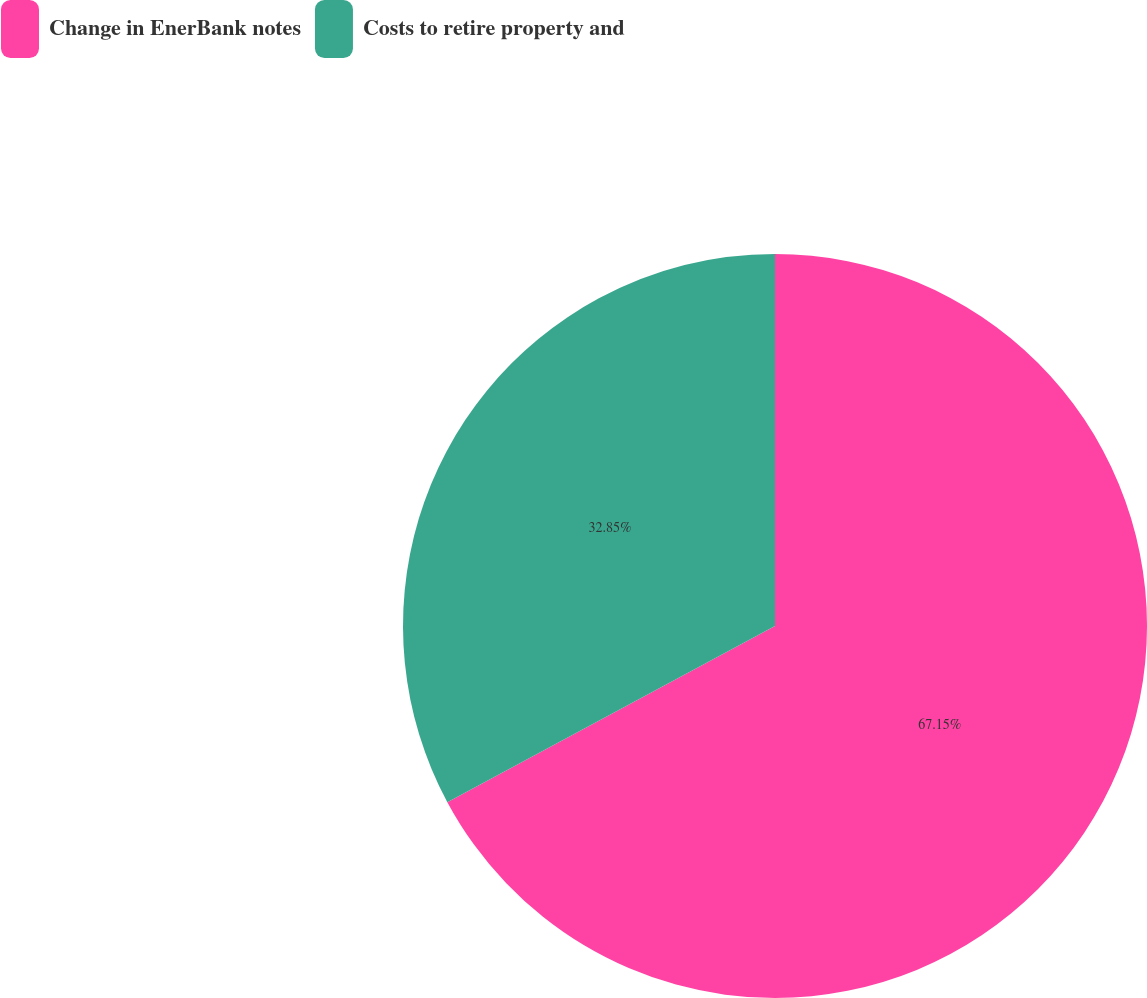Convert chart. <chart><loc_0><loc_0><loc_500><loc_500><pie_chart><fcel>Change in EnerBank notes<fcel>Costs to retire property and<nl><fcel>67.15%<fcel>32.85%<nl></chart> 